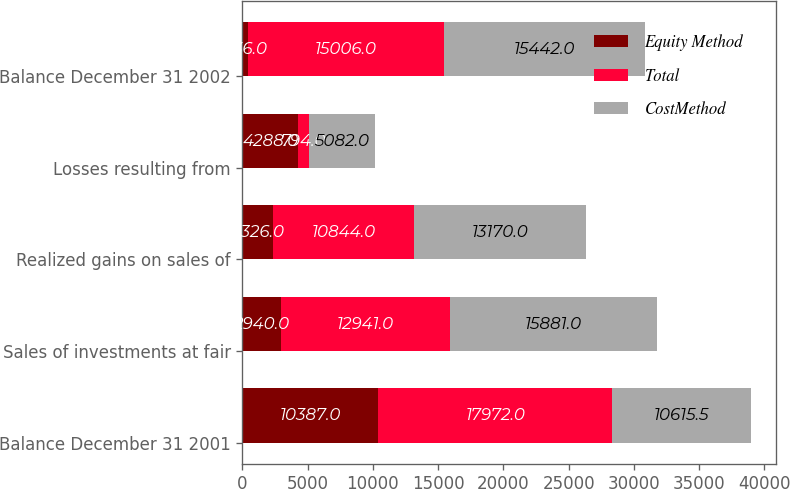Convert chart to OTSL. <chart><loc_0><loc_0><loc_500><loc_500><stacked_bar_chart><ecel><fcel>Balance December 31 2001<fcel>Sales of investments at fair<fcel>Realized gains on sales of<fcel>Losses resulting from<fcel>Balance December 31 2002<nl><fcel>Equity Method<fcel>10387<fcel>2940<fcel>2326<fcel>4288<fcel>436<nl><fcel>Total<fcel>17972<fcel>12941<fcel>10844<fcel>794<fcel>15006<nl><fcel>CostMethod<fcel>10615.5<fcel>15881<fcel>13170<fcel>5082<fcel>15442<nl></chart> 